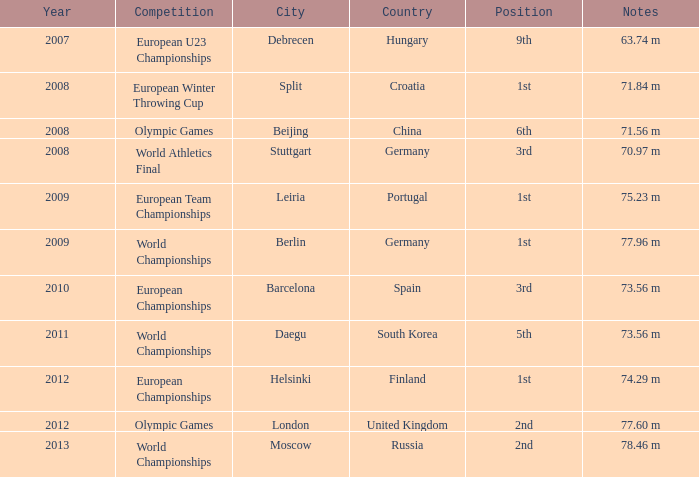In which year does the 9th spot occur? 2007.0. 